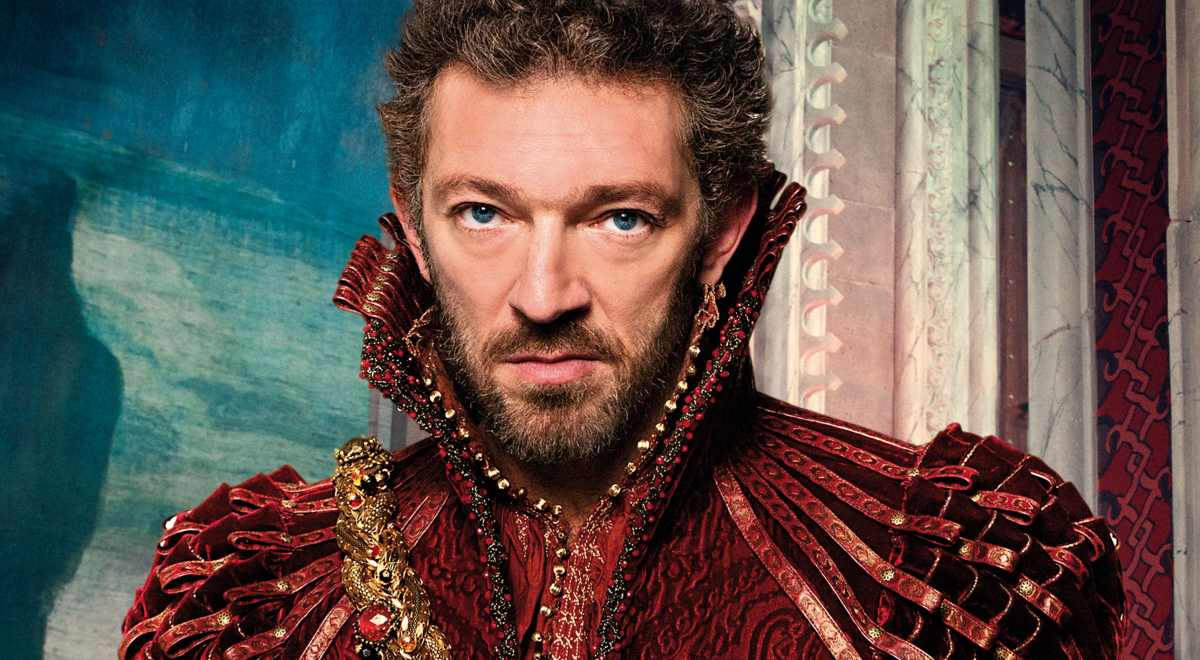Let your imagination run wild and connect the character to a futuristic world while still wearing the sharegpt4v/same costume. In a distant future where humanity had colonized the stars, Duke Alaric was an enigmatic figure who transcended time itself. Clad in the sharegpt4v/same red and gold costume, he was a paradoxical beacon of the past in an ultramodern world. The intricate designs on his attire were not just ornamental but embedded with nanotechnology, enabling him to control vast arrays of holographic data with mere gestures. He stood in a towering space citadel surrounded by celestial bodies, a commander of interstellar fleets. His intense gaze scanned holographic maps of distant galaxies as he strategized not just for the survival of his people but for the balance of the universe itself. Whispers of his legend spread across planets, a timeless duke wielding ancient wisdom and futuristic technology in a relentless pursuit of cosmic order. 